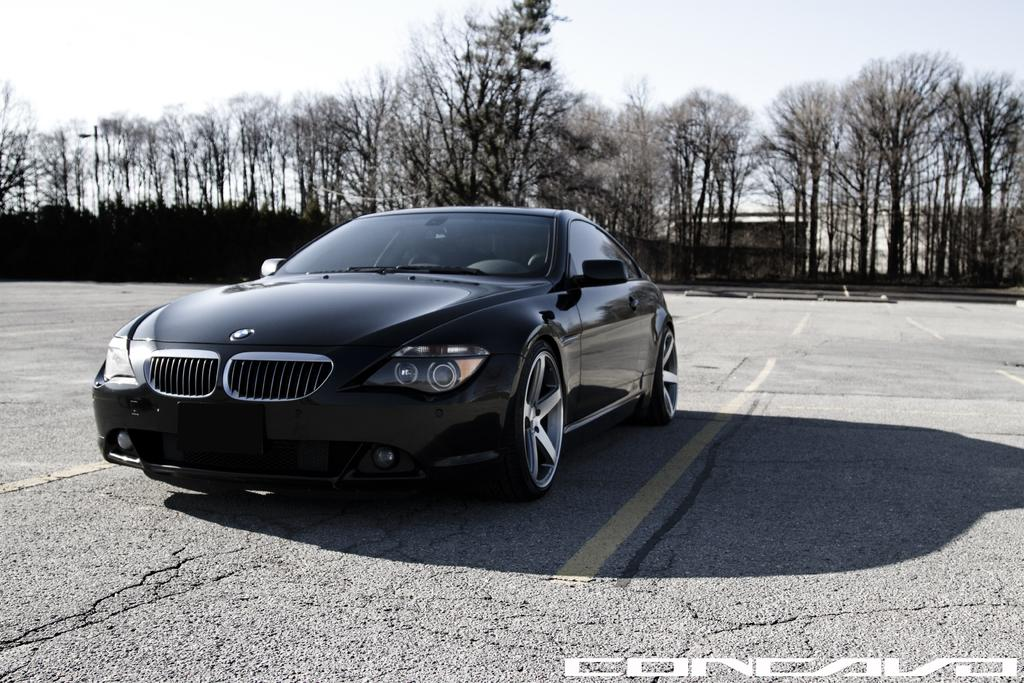What is the main subject of the image? There is a car on the road in the image. What can be seen in the background of the image? Trees and the sky are visible in the background of the image. Where is the text located in the image? The text is present in the bottom right side of the image. What is the rate of death for the passengers in the car in the image? There is no information about the passengers or their well-being in the image, so it is impossible to determine the rate of death. 